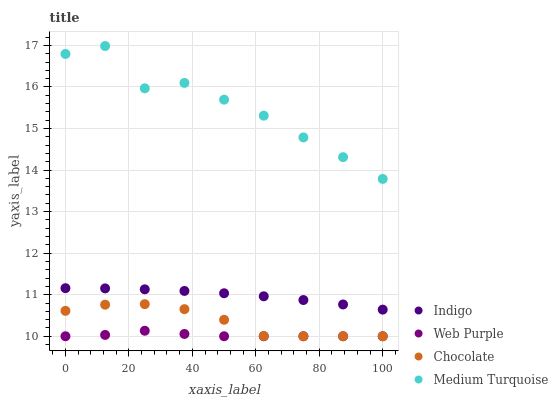Does Web Purple have the minimum area under the curve?
Answer yes or no. Yes. Does Medium Turquoise have the maximum area under the curve?
Answer yes or no. Yes. Does Indigo have the minimum area under the curve?
Answer yes or no. No. Does Indigo have the maximum area under the curve?
Answer yes or no. No. Is Indigo the smoothest?
Answer yes or no. Yes. Is Medium Turquoise the roughest?
Answer yes or no. Yes. Is Medium Turquoise the smoothest?
Answer yes or no. No. Is Indigo the roughest?
Answer yes or no. No. Does Web Purple have the lowest value?
Answer yes or no. Yes. Does Indigo have the lowest value?
Answer yes or no. No. Does Medium Turquoise have the highest value?
Answer yes or no. Yes. Does Indigo have the highest value?
Answer yes or no. No. Is Web Purple less than Indigo?
Answer yes or no. Yes. Is Medium Turquoise greater than Web Purple?
Answer yes or no. Yes. Does Chocolate intersect Web Purple?
Answer yes or no. Yes. Is Chocolate less than Web Purple?
Answer yes or no. No. Is Chocolate greater than Web Purple?
Answer yes or no. No. Does Web Purple intersect Indigo?
Answer yes or no. No. 